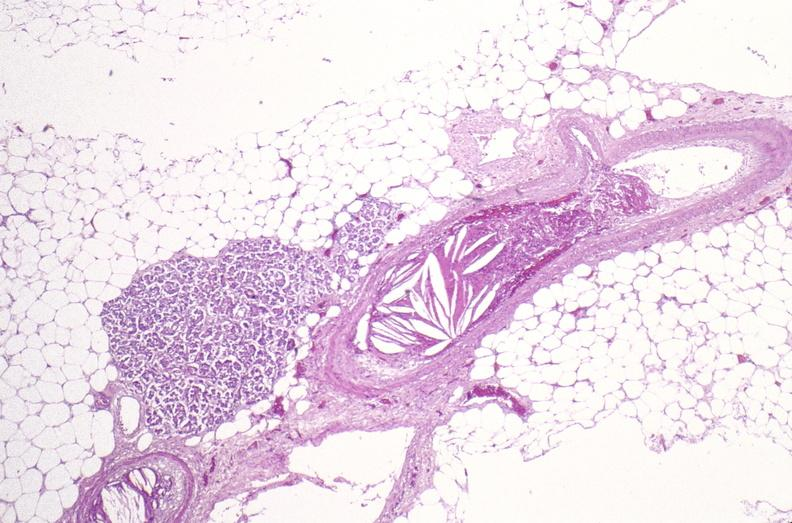what is present?
Answer the question using a single word or phrase. Soft tissue 